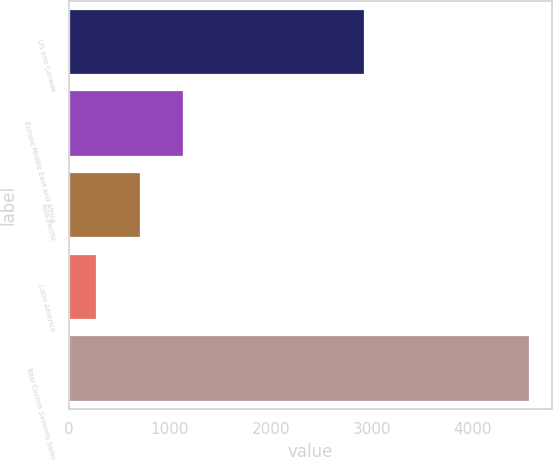Convert chart. <chart><loc_0><loc_0><loc_500><loc_500><bar_chart><fcel>US and Canada<fcel>Europe Middle East and Africa<fcel>Asia-Pacific<fcel>Latin America<fcel>Total Control Systems Sales<nl><fcel>2923.6<fcel>1127.46<fcel>699.48<fcel>271.5<fcel>4551.3<nl></chart> 